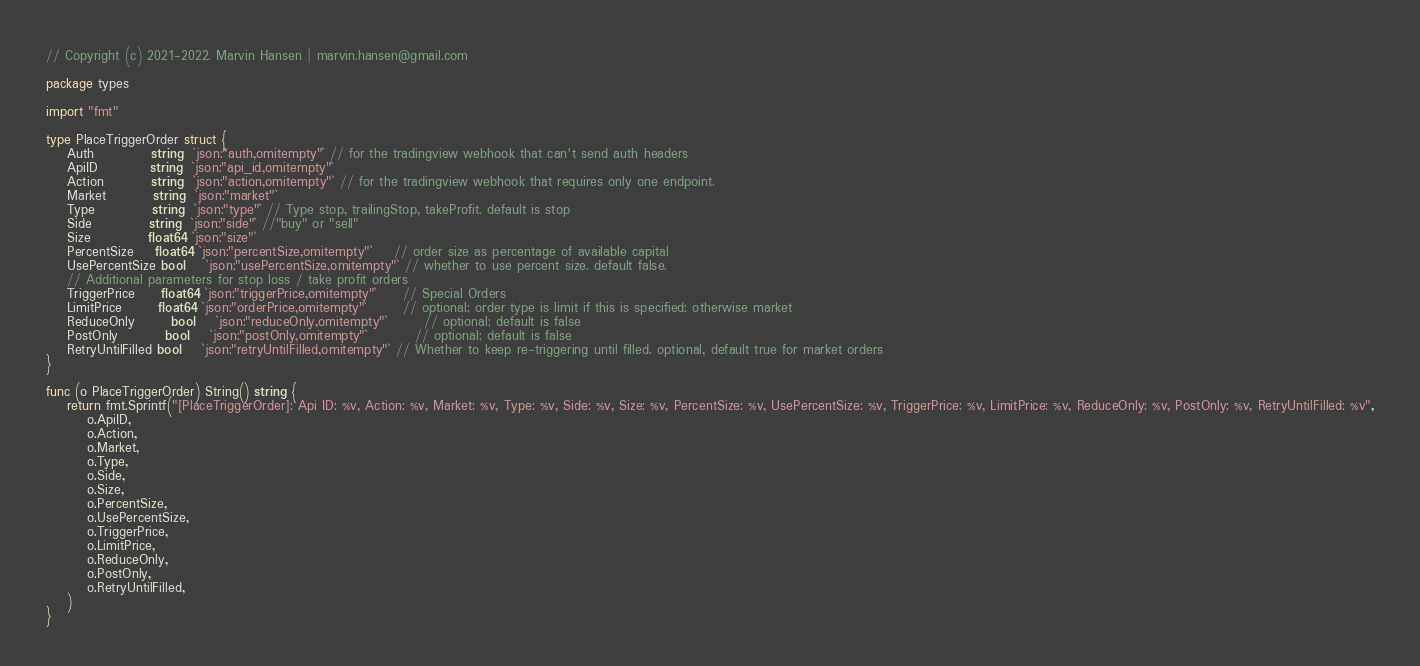<code> <loc_0><loc_0><loc_500><loc_500><_Go_>// Copyright (c) 2021-2022. Marvin Hansen | marvin.hansen@gmail.com

package types

import "fmt"

type PlaceTriggerOrder struct {
	Auth           string  `json:"auth,omitempty"` // for the tradingview webhook that can't send auth headers
	ApiID          string  `json:"api_id,omitempty"`
	Action         string  `json:"action,omitempty"` // for the tradingview webhook that requires only one endpoint.
	Market         string  `json:"market"`
	Type           string  `json:"type"` // Type stop, trailingStop, takeProfit. default is stop
	Side           string  `json:"side"` //"buy" or "sell"
	Size           float64 `json:"size"`
	PercentSize    float64 `json:"percentSize,omitempty"`    // order size as percentage of available capital
	UsePercentSize bool    `json:"usePercentSize,omitempty"` // whether to use percent size. default false.
	// Additional parameters for stop loss / take profit orders
	TriggerPrice     float64 `json:"triggerPrice,omitempty"`     // Special Orders
	LimitPrice       float64 `json:"orderPrice,omitempty"`       // optional; order type is limit if this is specified; otherwise market
	ReduceOnly       bool    `json:"reduceOnly,omitempty"`       // optional; default is false
	PostOnly         bool    `json:"postOnly,omitempty"`         // optional; default is false
	RetryUntilFilled bool    `json:"retryUntilFilled,omitempty"` // Whether to keep re-triggering until filled. optional, default true for market orders
}

func (o PlaceTriggerOrder) String() string {
	return fmt.Sprintf("[PlaceTriggerOrder]: Api ID: %v, Action: %v, Market: %v, Type: %v, Side: %v, Size: %v, PercentSize: %v, UsePercentSize: %v, TriggerPrice: %v, LimitPrice: %v, ReduceOnly: %v, PostOnly: %v, RetryUntilFilled: %v",
		o.ApiID,
		o.Action,
		o.Market,
		o.Type,
		o.Side,
		o.Size,
		o.PercentSize,
		o.UsePercentSize,
		o.TriggerPrice,
		o.LimitPrice,
		o.ReduceOnly,
		o.PostOnly,
		o.RetryUntilFilled,
	)
}
</code> 